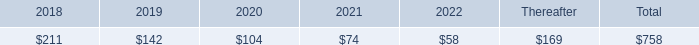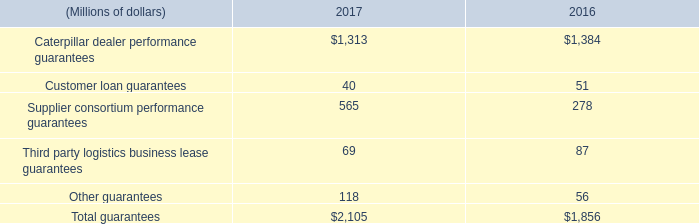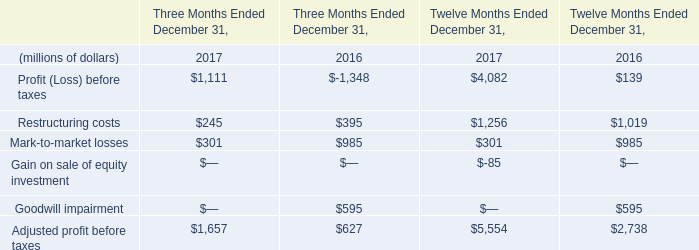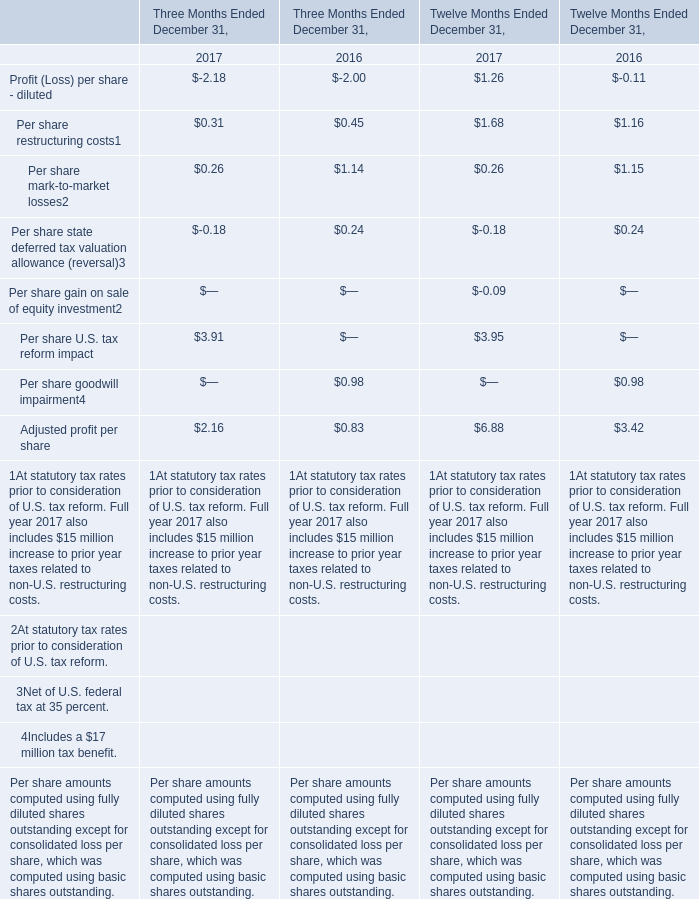Which year / section is Per share mark-to-market losses in Twelve Months Ended December 31 the lowest? 
Answer: 2017. 